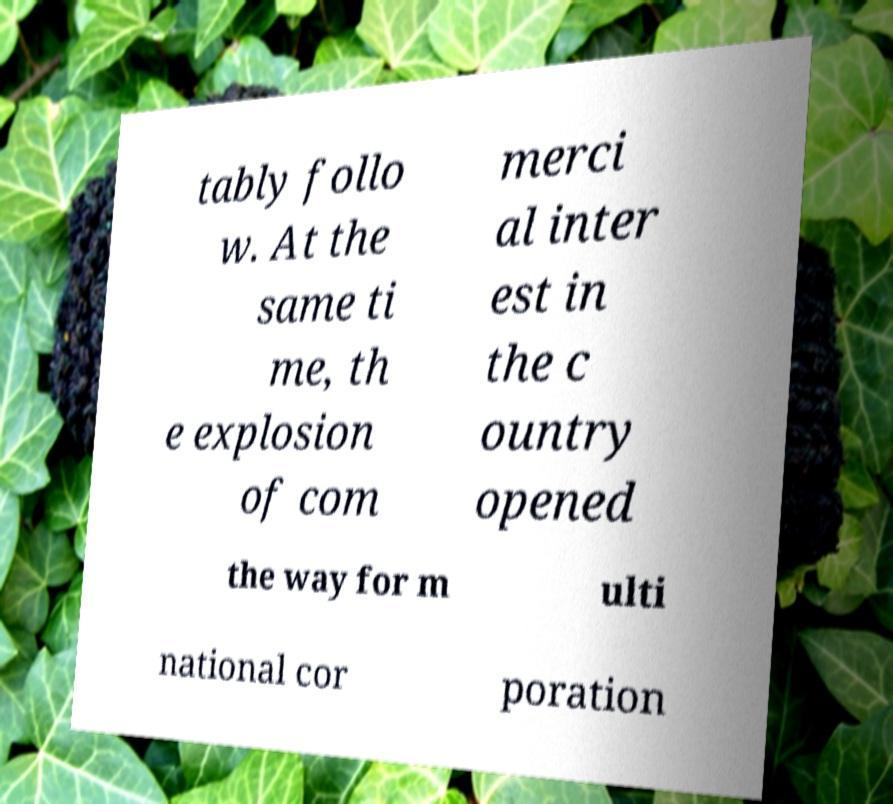I need the written content from this picture converted into text. Can you do that? tably follo w. At the same ti me, th e explosion of com merci al inter est in the c ountry opened the way for m ulti national cor poration 